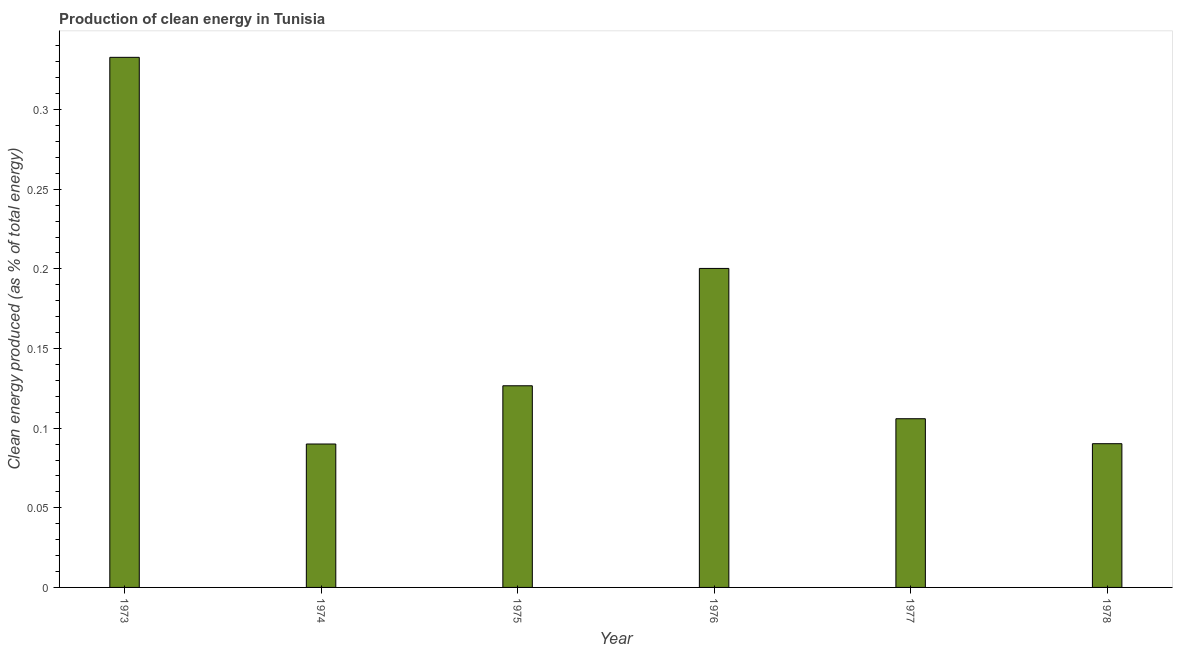What is the title of the graph?
Offer a very short reply. Production of clean energy in Tunisia. What is the label or title of the X-axis?
Offer a terse response. Year. What is the label or title of the Y-axis?
Offer a very short reply. Clean energy produced (as % of total energy). What is the production of clean energy in 1973?
Keep it short and to the point. 0.33. Across all years, what is the maximum production of clean energy?
Provide a short and direct response. 0.33. Across all years, what is the minimum production of clean energy?
Ensure brevity in your answer.  0.09. In which year was the production of clean energy minimum?
Your response must be concise. 1974. What is the sum of the production of clean energy?
Your answer should be very brief. 0.95. What is the difference between the production of clean energy in 1975 and 1976?
Make the answer very short. -0.07. What is the average production of clean energy per year?
Give a very brief answer. 0.16. What is the median production of clean energy?
Your answer should be compact. 0.12. What is the ratio of the production of clean energy in 1973 to that in 1975?
Offer a very short reply. 2.63. Is the difference between the production of clean energy in 1976 and 1978 greater than the difference between any two years?
Provide a succinct answer. No. What is the difference between the highest and the second highest production of clean energy?
Provide a short and direct response. 0.13. Is the sum of the production of clean energy in 1974 and 1978 greater than the maximum production of clean energy across all years?
Keep it short and to the point. No. What is the difference between the highest and the lowest production of clean energy?
Give a very brief answer. 0.24. Are all the bars in the graph horizontal?
Your answer should be very brief. No. What is the difference between two consecutive major ticks on the Y-axis?
Give a very brief answer. 0.05. What is the Clean energy produced (as % of total energy) of 1973?
Give a very brief answer. 0.33. What is the Clean energy produced (as % of total energy) in 1974?
Provide a succinct answer. 0.09. What is the Clean energy produced (as % of total energy) in 1975?
Keep it short and to the point. 0.13. What is the Clean energy produced (as % of total energy) in 1976?
Make the answer very short. 0.2. What is the Clean energy produced (as % of total energy) of 1977?
Keep it short and to the point. 0.11. What is the Clean energy produced (as % of total energy) in 1978?
Make the answer very short. 0.09. What is the difference between the Clean energy produced (as % of total energy) in 1973 and 1974?
Give a very brief answer. 0.24. What is the difference between the Clean energy produced (as % of total energy) in 1973 and 1975?
Your answer should be compact. 0.21. What is the difference between the Clean energy produced (as % of total energy) in 1973 and 1976?
Give a very brief answer. 0.13. What is the difference between the Clean energy produced (as % of total energy) in 1973 and 1977?
Keep it short and to the point. 0.23. What is the difference between the Clean energy produced (as % of total energy) in 1973 and 1978?
Your answer should be compact. 0.24. What is the difference between the Clean energy produced (as % of total energy) in 1974 and 1975?
Make the answer very short. -0.04. What is the difference between the Clean energy produced (as % of total energy) in 1974 and 1976?
Provide a succinct answer. -0.11. What is the difference between the Clean energy produced (as % of total energy) in 1974 and 1977?
Make the answer very short. -0.02. What is the difference between the Clean energy produced (as % of total energy) in 1974 and 1978?
Provide a succinct answer. -0. What is the difference between the Clean energy produced (as % of total energy) in 1975 and 1976?
Provide a succinct answer. -0.07. What is the difference between the Clean energy produced (as % of total energy) in 1975 and 1977?
Offer a very short reply. 0.02. What is the difference between the Clean energy produced (as % of total energy) in 1975 and 1978?
Your answer should be very brief. 0.04. What is the difference between the Clean energy produced (as % of total energy) in 1976 and 1977?
Your answer should be very brief. 0.09. What is the difference between the Clean energy produced (as % of total energy) in 1976 and 1978?
Ensure brevity in your answer.  0.11. What is the difference between the Clean energy produced (as % of total energy) in 1977 and 1978?
Ensure brevity in your answer.  0.02. What is the ratio of the Clean energy produced (as % of total energy) in 1973 to that in 1974?
Provide a short and direct response. 3.7. What is the ratio of the Clean energy produced (as % of total energy) in 1973 to that in 1975?
Your response must be concise. 2.63. What is the ratio of the Clean energy produced (as % of total energy) in 1973 to that in 1976?
Offer a very short reply. 1.66. What is the ratio of the Clean energy produced (as % of total energy) in 1973 to that in 1977?
Make the answer very short. 3.14. What is the ratio of the Clean energy produced (as % of total energy) in 1973 to that in 1978?
Your answer should be compact. 3.69. What is the ratio of the Clean energy produced (as % of total energy) in 1974 to that in 1975?
Give a very brief answer. 0.71. What is the ratio of the Clean energy produced (as % of total energy) in 1974 to that in 1976?
Your answer should be very brief. 0.45. What is the ratio of the Clean energy produced (as % of total energy) in 1974 to that in 1978?
Keep it short and to the point. 1. What is the ratio of the Clean energy produced (as % of total energy) in 1975 to that in 1976?
Provide a succinct answer. 0.63. What is the ratio of the Clean energy produced (as % of total energy) in 1975 to that in 1977?
Make the answer very short. 1.2. What is the ratio of the Clean energy produced (as % of total energy) in 1975 to that in 1978?
Provide a short and direct response. 1.4. What is the ratio of the Clean energy produced (as % of total energy) in 1976 to that in 1977?
Provide a succinct answer. 1.89. What is the ratio of the Clean energy produced (as % of total energy) in 1976 to that in 1978?
Ensure brevity in your answer.  2.22. What is the ratio of the Clean energy produced (as % of total energy) in 1977 to that in 1978?
Your answer should be very brief. 1.17. 